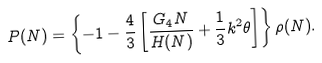Convert formula to latex. <formula><loc_0><loc_0><loc_500><loc_500>P ( N ) = \left \{ - 1 - \frac { 4 } { 3 } \left [ \frac { G _ { 4 } N } { H ( N ) } + \frac { 1 } { 3 } k ^ { 2 } \theta \right ] \right \} \rho ( N ) .</formula> 